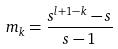<formula> <loc_0><loc_0><loc_500><loc_500>m _ { k } = \frac { s ^ { l + 1 - k } - s } { s - 1 }</formula> 